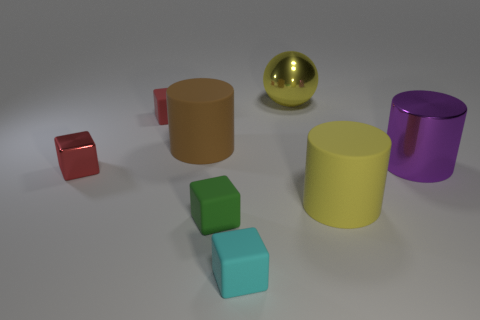Subtract all matte cubes. How many cubes are left? 1 Subtract all blue cylinders. How many red blocks are left? 2 Subtract all green cubes. How many cubes are left? 3 Add 1 spheres. How many objects exist? 9 Subtract all cyan blocks. Subtract all brown balls. How many blocks are left? 3 Subtract all cylinders. How many objects are left? 5 Subtract all small green rubber objects. Subtract all green blocks. How many objects are left? 6 Add 3 small cyan rubber things. How many small cyan rubber things are left? 4 Add 8 tiny green metal spheres. How many tiny green metal spheres exist? 8 Subtract 0 gray spheres. How many objects are left? 8 